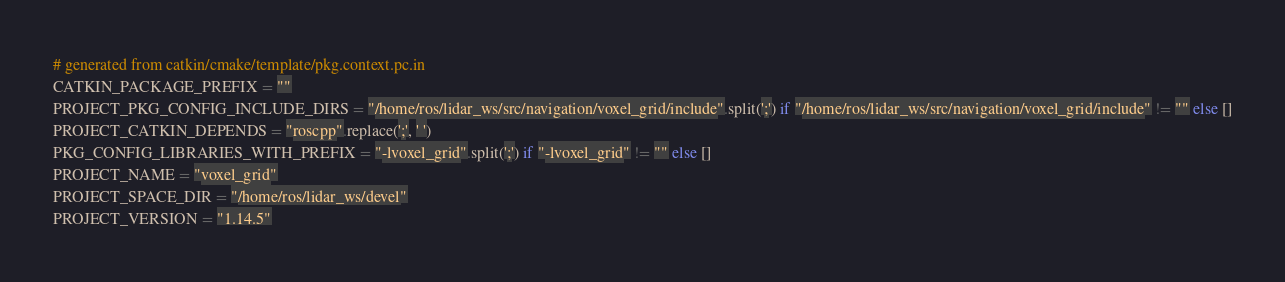Convert code to text. <code><loc_0><loc_0><loc_500><loc_500><_Python_># generated from catkin/cmake/template/pkg.context.pc.in
CATKIN_PACKAGE_PREFIX = ""
PROJECT_PKG_CONFIG_INCLUDE_DIRS = "/home/ros/lidar_ws/src/navigation/voxel_grid/include".split(';') if "/home/ros/lidar_ws/src/navigation/voxel_grid/include" != "" else []
PROJECT_CATKIN_DEPENDS = "roscpp".replace(';', ' ')
PKG_CONFIG_LIBRARIES_WITH_PREFIX = "-lvoxel_grid".split(';') if "-lvoxel_grid" != "" else []
PROJECT_NAME = "voxel_grid"
PROJECT_SPACE_DIR = "/home/ros/lidar_ws/devel"
PROJECT_VERSION = "1.14.5"
</code> 